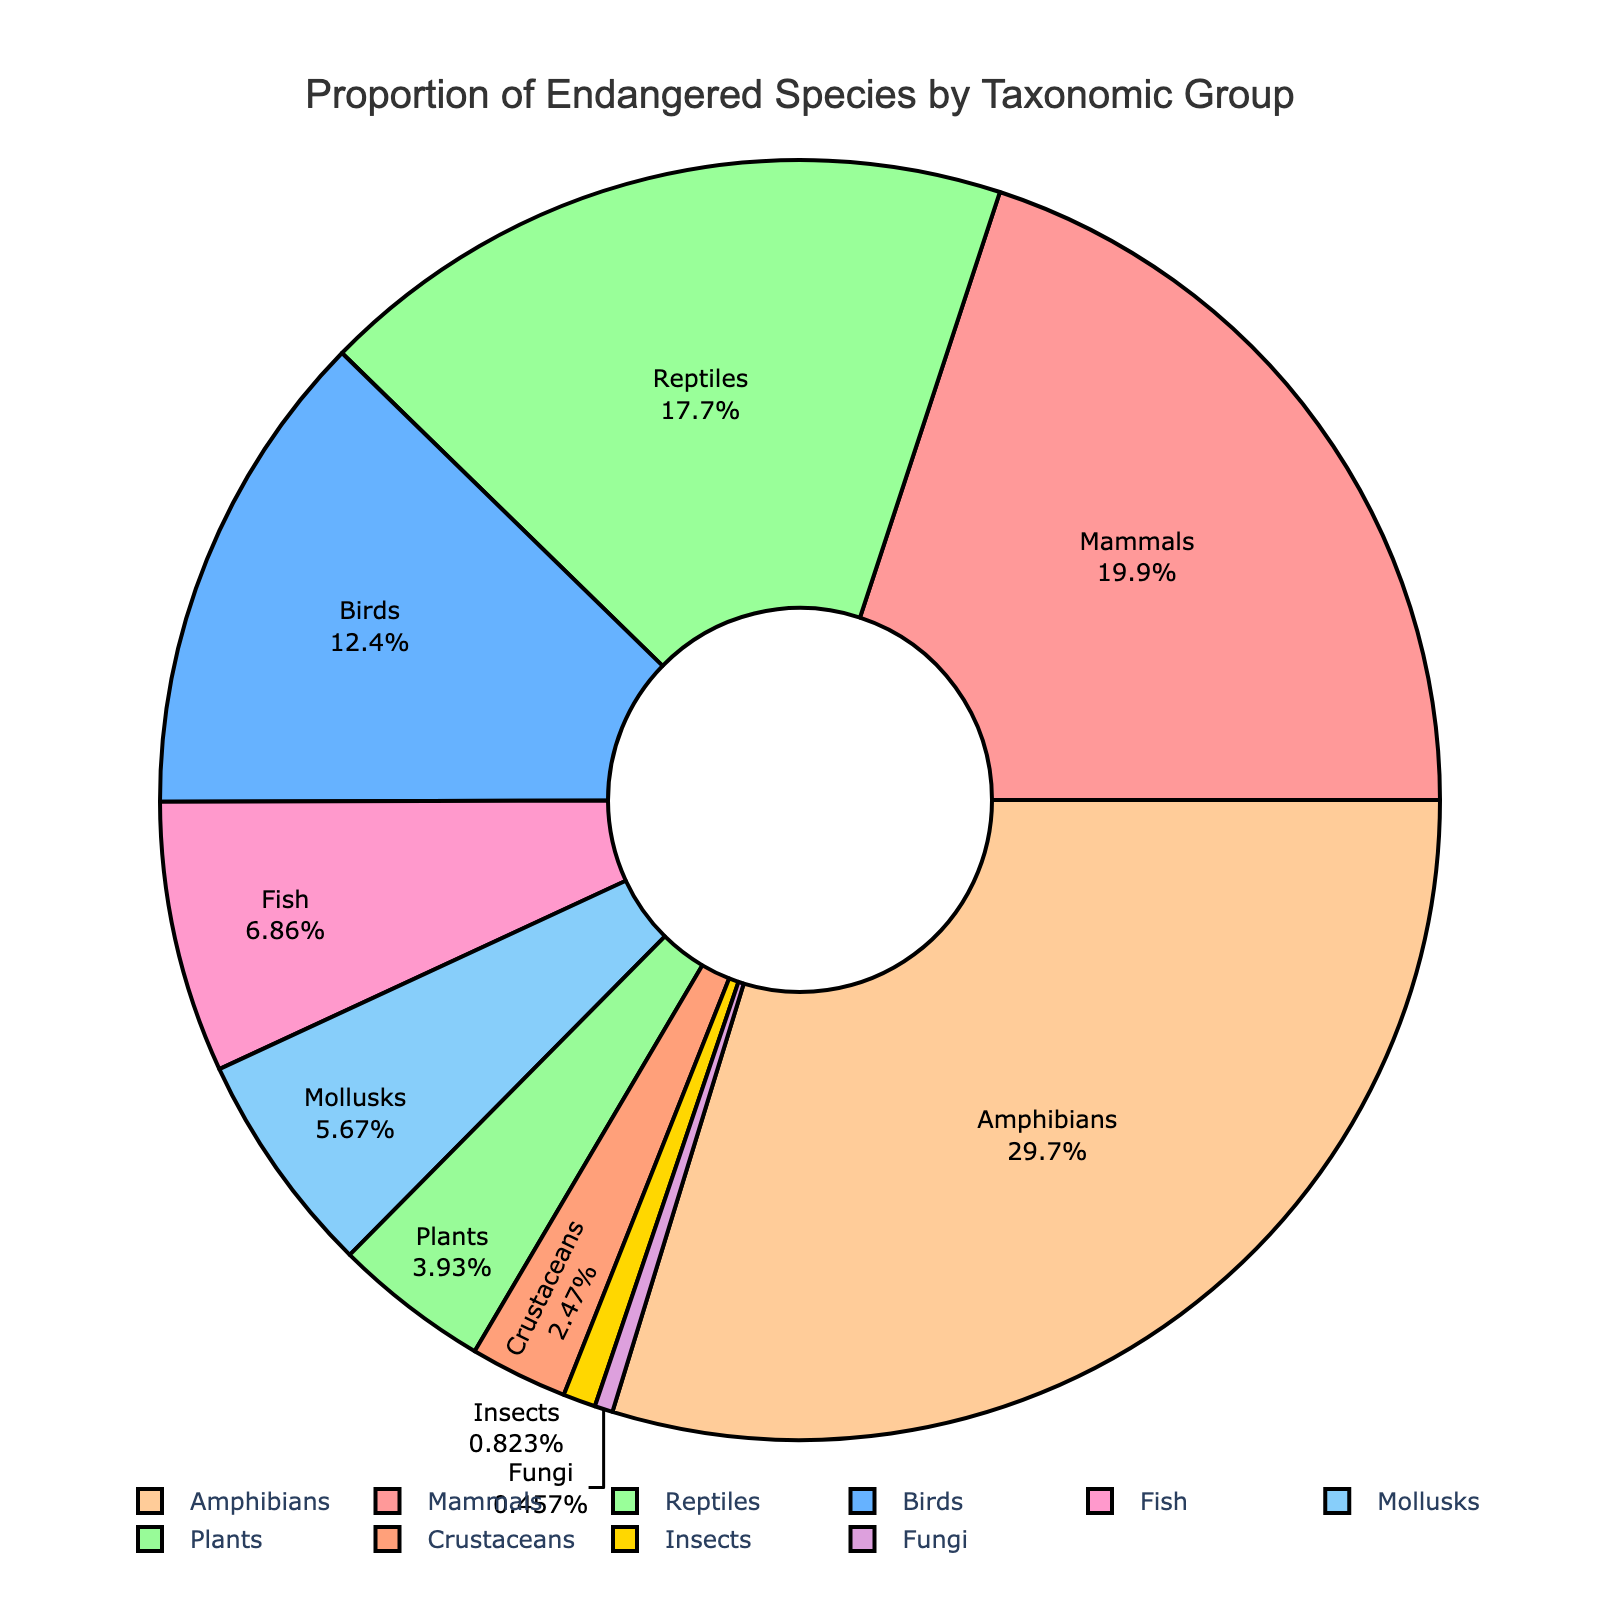What taxonomic group has the highest proportion of endangered species? Identify the slice with the largest percentage labeled in the chart
Answer: Amphibians Which taxonomic group has a higher proportion of endangered species, Mammals or Reptiles? Compare the percentage values of both Mammals (21.8%) and Reptiles (19.4%)
Answer: Mammals What is the combined proportion of endangered species for Mammals and Birds? Add the proportion of endangered species for Mammals (21.8%) and Birds (13.5%). 21.8 + 13.5 = 35.3
Answer: 35.3 How does the proportion of endangered Fish compare to that of Insects? Compare the percentage values shown: Fish (7.5%) and Insects (0.9%)
Answer: Fish have a higher proportion What's the proportion gap between the largest and smallest taxonomic groups for endangered species? Determine the largest (Amphibians, 32.5%) and the smallest (Fungi, 0.5%), then subtract the smallest from the largest (32.5 - 0.5). 32.5 - 0.5 = 32
Answer: 32 Which three taxonomic groups have proportions of endangered species less than 5%? Identify the groups with less than 5% Endangered Species: Insects (0.9%), Fungi (0.5%), Plants (4.3%)
Answer: Insects, Fungi, Plants Is the proportion of endangered species in Crustaceans greater than double that of Fungi? Compare Crustaceans (2.7%) with double of Fungi (0.5% * 2 = 1%). 2.7% > 1%
Answer: Yes What is the average proportion of endangered species for Reptiles, Amphibians, and Fish? Add the proportions (Reptiles: 19.4%, Amphibians: 32.5%, Fish: 7.5%), divide by 3: (19.4 + 32.5 + 7.5) / 3 = 59.4 / 3 = 19.8
Answer: 19.8 Which taxonomic group represented by the yellow slice in the chart? Identify the taxonomic group labeled in yellow in the pie chart
Answer: Fish Is the proportion of endangered species for Mollusks closer to that of Crustaceans or Fish? Compare the proportions: Mollusks (6.2%), Crustaceans (2.7%), Fish (7.5%), and find the closest value to 6.2%
Answer: Fish 